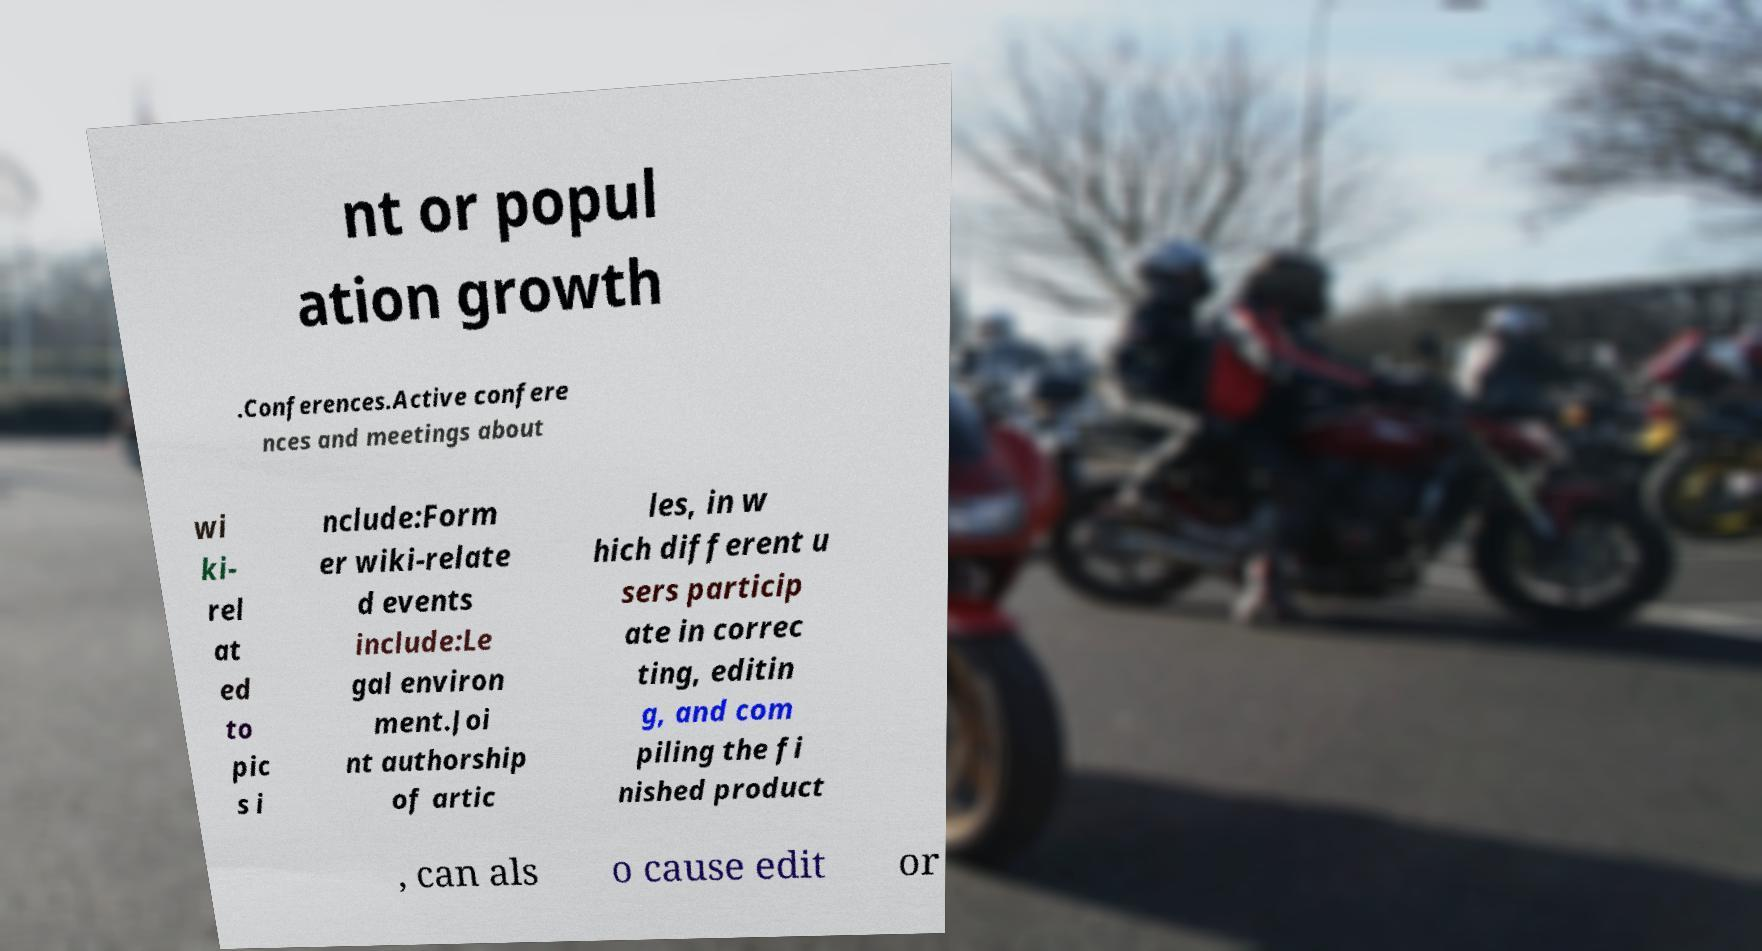What messages or text are displayed in this image? I need them in a readable, typed format. nt or popul ation growth .Conferences.Active confere nces and meetings about wi ki- rel at ed to pic s i nclude:Form er wiki-relate d events include:Le gal environ ment.Joi nt authorship of artic les, in w hich different u sers particip ate in correc ting, editin g, and com piling the fi nished product , can als o cause edit or 